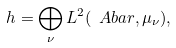Convert formula to latex. <formula><loc_0><loc_0><loc_500><loc_500>\ h = \bigoplus _ { \nu } L ^ { 2 } ( \ A b a r , \mu _ { \nu } ) ,</formula> 